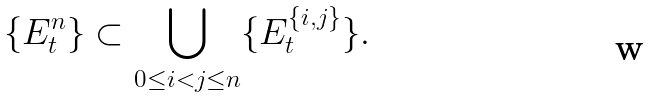Convert formula to latex. <formula><loc_0><loc_0><loc_500><loc_500>\{ E _ { t } ^ { n } \} \subset \bigcup _ { 0 \leq i < j \leq n } \{ E ^ { \{ i , j \} } _ { t } \} .</formula> 